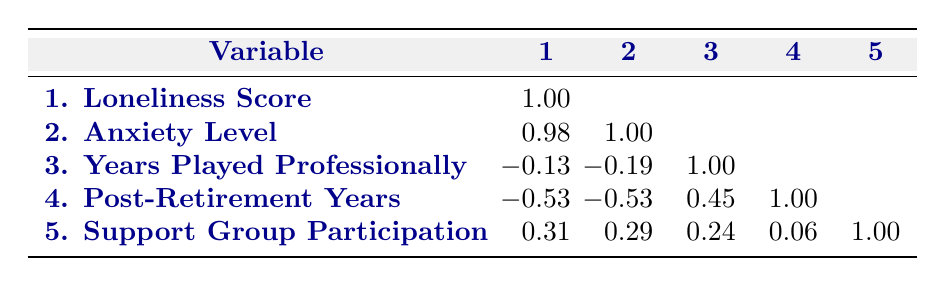What is the correlation between the loneliness score and the anxiety level? The table shows a correlation value of 0.98 between loneliness score and anxiety level, indicating a very strong positive relationship. This means as loneliness increases, anxiety levels also tend to increase.
Answer: 0.98 How many players participated in support groups? In the table, we can see that support group participation values are 1 (yes) for John Doe, David Johnson, and Chris Lee, totaling 3 players.
Answer: 3 Is there a negative correlation between post-retirement years and anxiety levels? The correlation value listed for post-retirement years and anxiety level is -0.53, which indicates a negative relationship. So as post-retirement years increase, anxiety levels tend to decrease.
Answer: Yes What is the average loneliness score of the players? The loneliness scores are 8, 5, 9, 4, and 7. Summing these gives 33, and dividing by the number of players (5) yields an average score of 6.6.
Answer: 6.6 Which player has the highest loneliness score? By examining the loneliness scores, David Johnson has the highest score at 9.
Answer: David Johnson What is the correlation between years played professionally and anxiety level? The correlation value between years played professionally and anxiety level is -0.19, suggesting a slight negative relationship, indicating that more years played does not significantly relate to anxiety levels.
Answer: -0.19 Based on the table, does more years played professionally correlate positively with support group participation? The correlation value between years played professionally and support group participation is 0.24, showing a slight positive correlation, but it is not strong enough to indicate a meaningful relationship.
Answer: No What is the difference in loneliness scores between the players with the highest and lowest anxiety levels? David Johnson has an anxiety level of 8 and a loneliness score of 9, while Chris Lee has an anxiety level of 4 and a loneliness score of 4. The difference in loneliness scores is 9 - 4 = 5.
Answer: 5 What is the correlation value among support group participation and anxiety levels? The correlation value between support group participation and anxiety levels is 0.29, indicating a slight positive correlation suggesting that those who participate in support groups may have slightly higher anxiety levels.
Answer: 0.29 